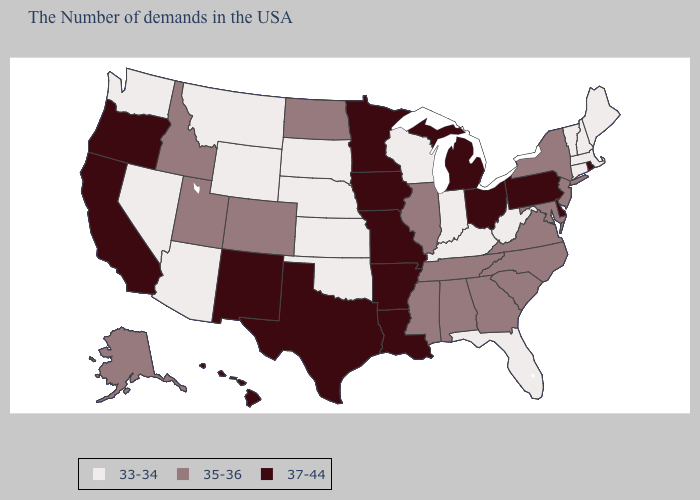Which states have the lowest value in the MidWest?
Concise answer only. Indiana, Wisconsin, Kansas, Nebraska, South Dakota. Name the states that have a value in the range 35-36?
Write a very short answer. New York, New Jersey, Maryland, Virginia, North Carolina, South Carolina, Georgia, Alabama, Tennessee, Illinois, Mississippi, North Dakota, Colorado, Utah, Idaho, Alaska. How many symbols are there in the legend?
Short answer required. 3. What is the value of Arkansas?
Keep it brief. 37-44. What is the lowest value in the West?
Quick response, please. 33-34. How many symbols are there in the legend?
Give a very brief answer. 3. Which states have the highest value in the USA?
Write a very short answer. Rhode Island, Delaware, Pennsylvania, Ohio, Michigan, Louisiana, Missouri, Arkansas, Minnesota, Iowa, Texas, New Mexico, California, Oregon, Hawaii. Does Colorado have a lower value than Michigan?
Answer briefly. Yes. Which states have the lowest value in the USA?
Be succinct. Maine, Massachusetts, New Hampshire, Vermont, Connecticut, West Virginia, Florida, Kentucky, Indiana, Wisconsin, Kansas, Nebraska, Oklahoma, South Dakota, Wyoming, Montana, Arizona, Nevada, Washington. Name the states that have a value in the range 33-34?
Quick response, please. Maine, Massachusetts, New Hampshire, Vermont, Connecticut, West Virginia, Florida, Kentucky, Indiana, Wisconsin, Kansas, Nebraska, Oklahoma, South Dakota, Wyoming, Montana, Arizona, Nevada, Washington. Name the states that have a value in the range 35-36?
Be succinct. New York, New Jersey, Maryland, Virginia, North Carolina, South Carolina, Georgia, Alabama, Tennessee, Illinois, Mississippi, North Dakota, Colorado, Utah, Idaho, Alaska. Name the states that have a value in the range 35-36?
Concise answer only. New York, New Jersey, Maryland, Virginia, North Carolina, South Carolina, Georgia, Alabama, Tennessee, Illinois, Mississippi, North Dakota, Colorado, Utah, Idaho, Alaska. Among the states that border Arkansas , does Louisiana have the highest value?
Write a very short answer. Yes. Does Michigan have the highest value in the MidWest?
Answer briefly. Yes. Name the states that have a value in the range 33-34?
Answer briefly. Maine, Massachusetts, New Hampshire, Vermont, Connecticut, West Virginia, Florida, Kentucky, Indiana, Wisconsin, Kansas, Nebraska, Oklahoma, South Dakota, Wyoming, Montana, Arizona, Nevada, Washington. 